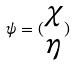Convert formula to latex. <formula><loc_0><loc_0><loc_500><loc_500>\psi = ( \begin{matrix} \chi \\ \eta \end{matrix} )</formula> 